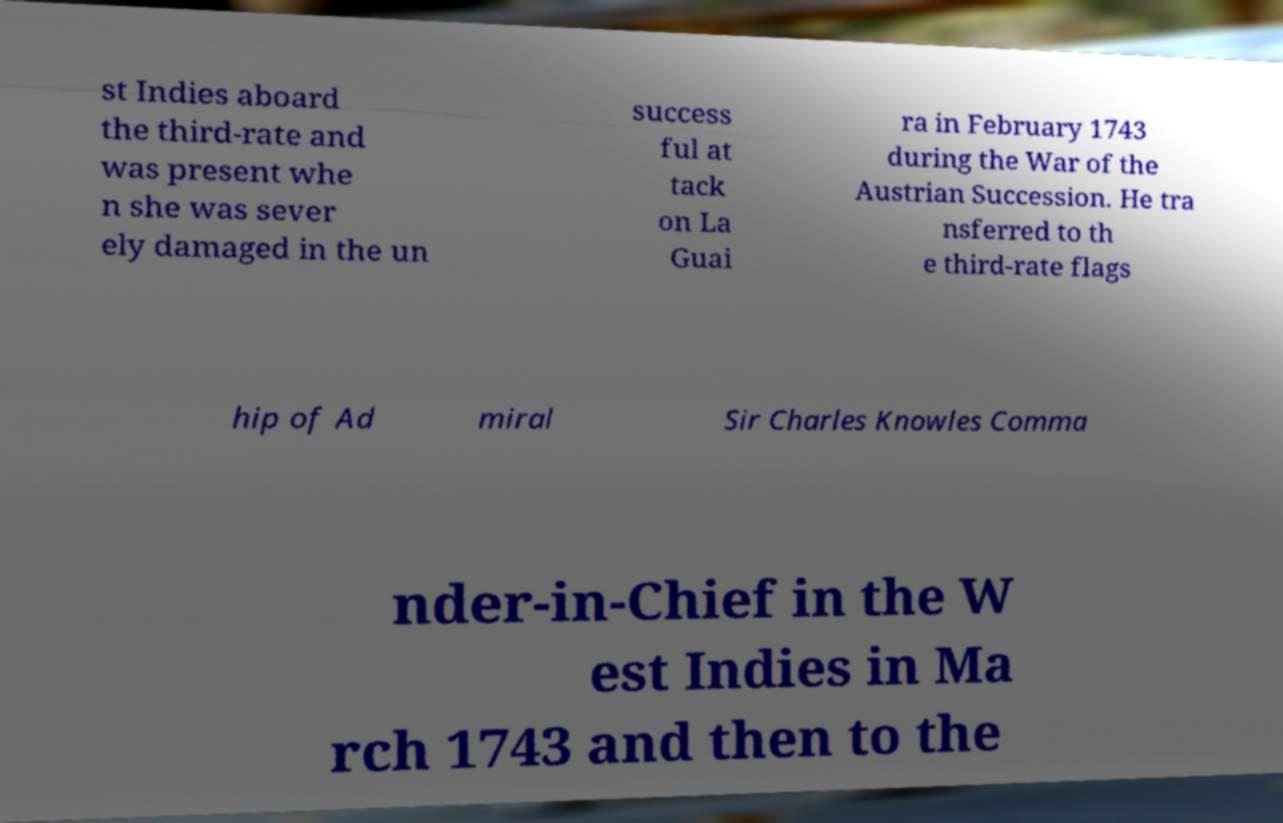Please identify and transcribe the text found in this image. st Indies aboard the third-rate and was present whe n she was sever ely damaged in the un success ful at tack on La Guai ra in February 1743 during the War of the Austrian Succession. He tra nsferred to th e third-rate flags hip of Ad miral Sir Charles Knowles Comma nder-in-Chief in the W est Indies in Ma rch 1743 and then to the 